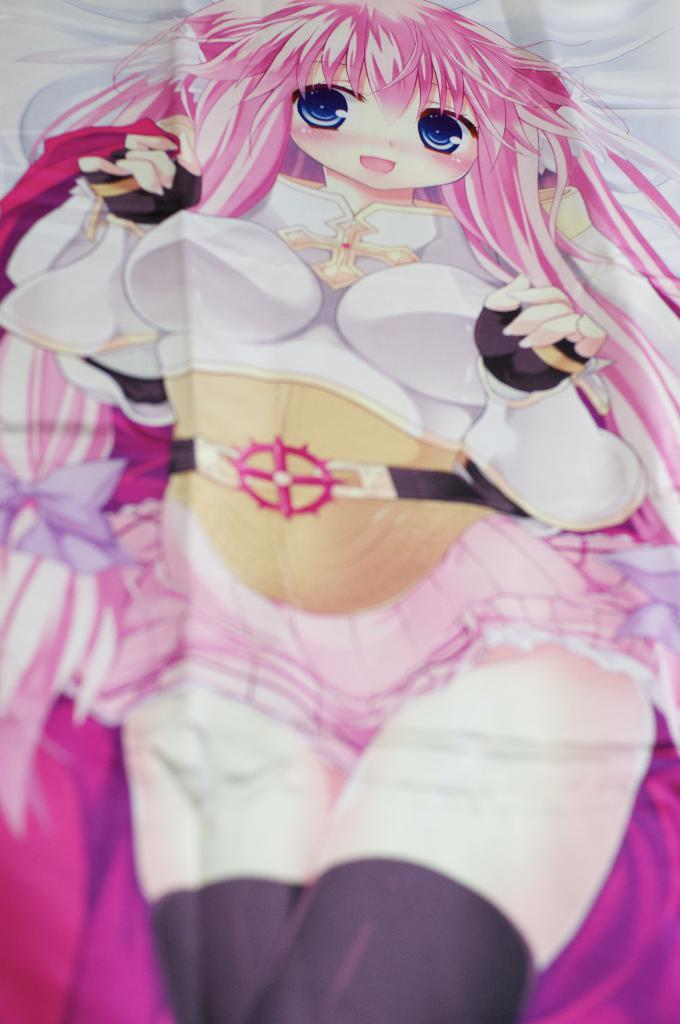What type of image is present in the picture? There is a cartoon image of a woman in the picture. What type of swing can be seen in the image? There is no swing present in the image; it features a cartoon image of a woman. What type of liquid is being poured by the woman in the image? There is no liquid or pouring action depicted in the image; it is a static cartoon image of a woman. 